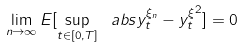Convert formula to latex. <formula><loc_0><loc_0><loc_500><loc_500>\lim _ { n \to \infty } E [ \sup _ { t \in [ 0 , T ] } \ a b s { y _ { t } ^ { \xi _ { n } } - y _ { t } ^ { \xi } } ^ { 2 } ] = 0</formula> 